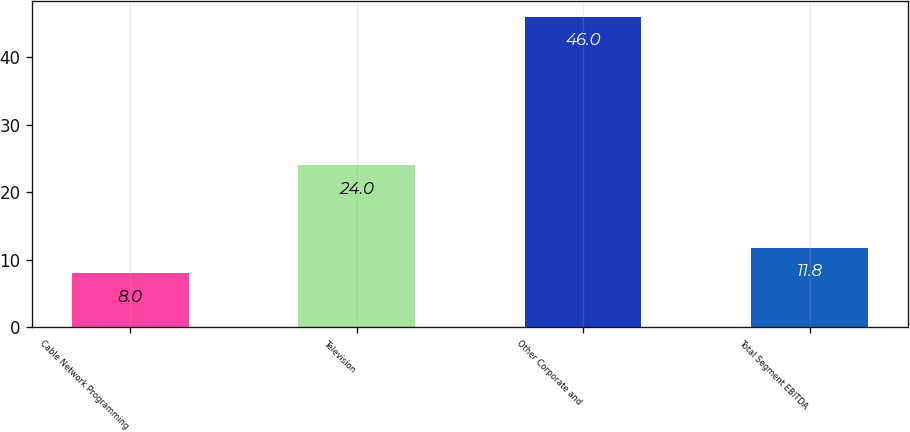Convert chart to OTSL. <chart><loc_0><loc_0><loc_500><loc_500><bar_chart><fcel>Cable Network Programming<fcel>Television<fcel>Other Corporate and<fcel>Total Segment EBITDA<nl><fcel>8<fcel>24<fcel>46<fcel>11.8<nl></chart> 